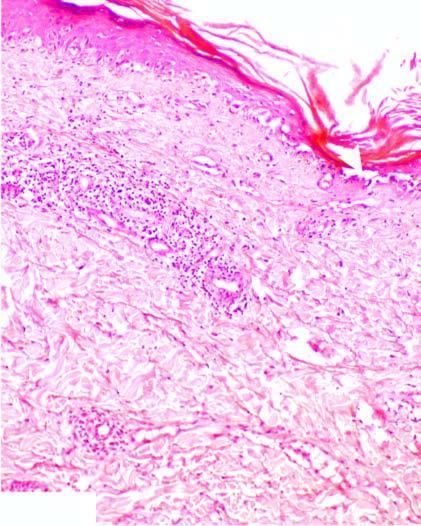s the affected area on right hyperkeratosis and follicular plugging?
Answer the question using a single word or phrase. No 